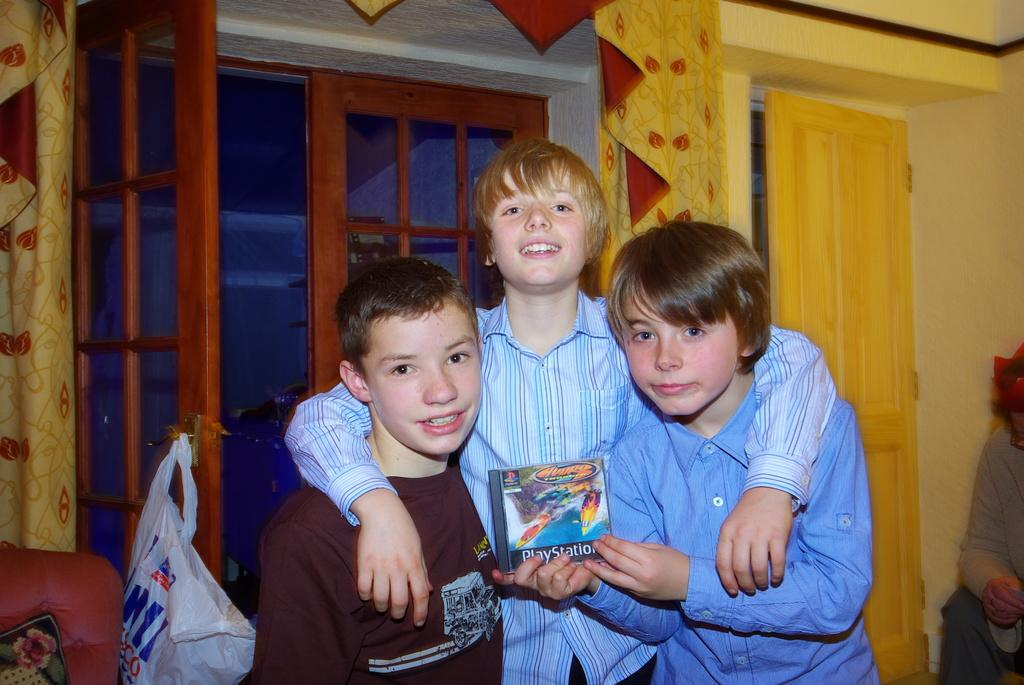What can be seen in the foreground of the image? There are children standing in the foreground of the image. What architectural features are present in the image? There are windows, curtains, and a door in the image. What is visible in the background of the image? There are other objects and polythene in the background of the image. What type of island can be seen in the background of the image? There is no island present in the image. What drug is being used by the children in the image? There is no drug use depicted in the image; it features children standing in the foreground. 